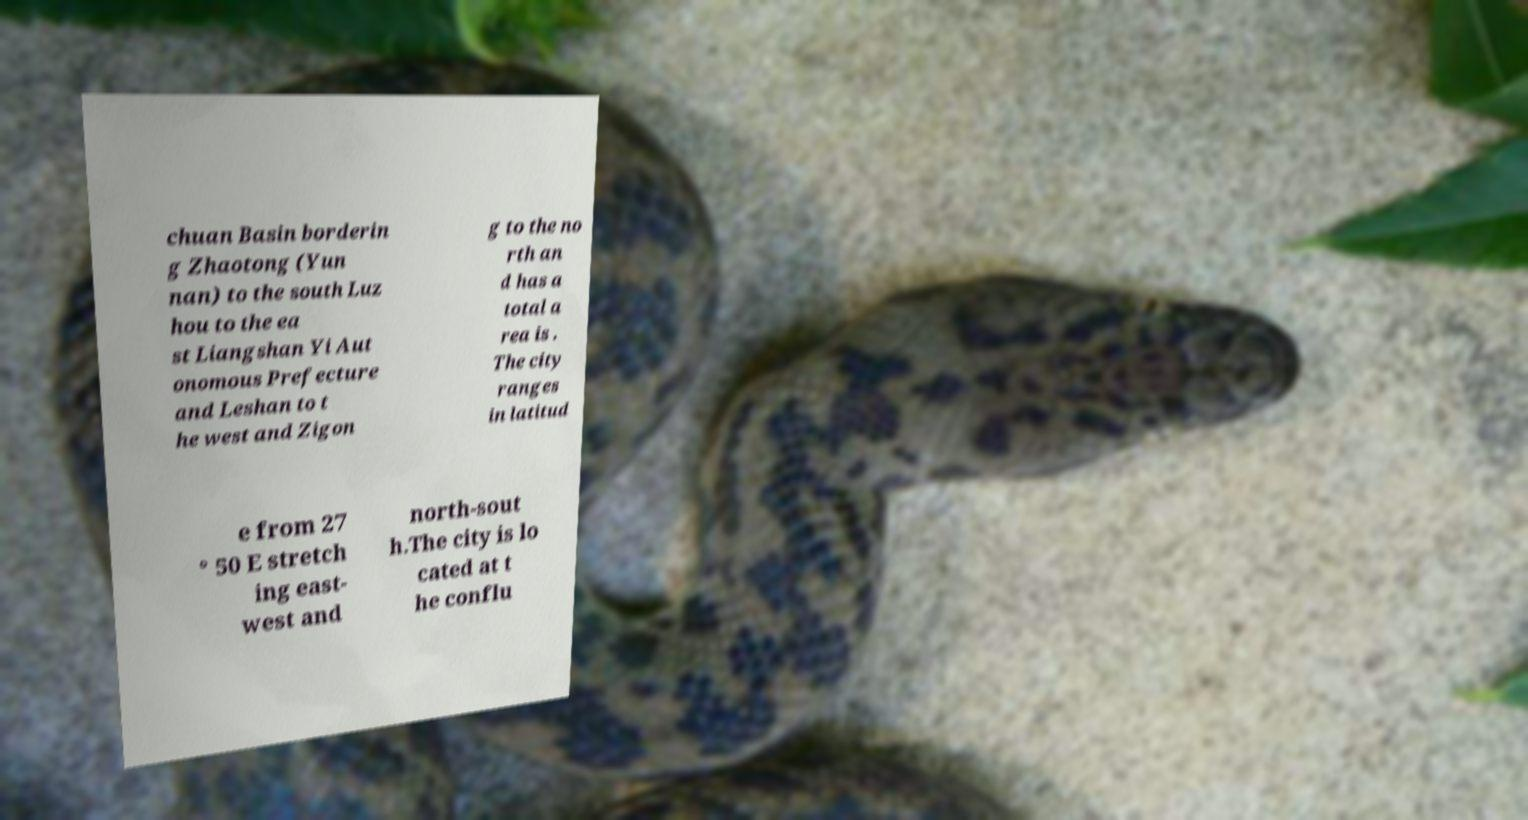I need the written content from this picture converted into text. Can you do that? chuan Basin borderin g Zhaotong (Yun nan) to the south Luz hou to the ea st Liangshan Yi Aut onomous Prefecture and Leshan to t he west and Zigon g to the no rth an d has a total a rea is . The city ranges in latitud e from 27 ° 50 E stretch ing east- west and north-sout h.The city is lo cated at t he conflu 